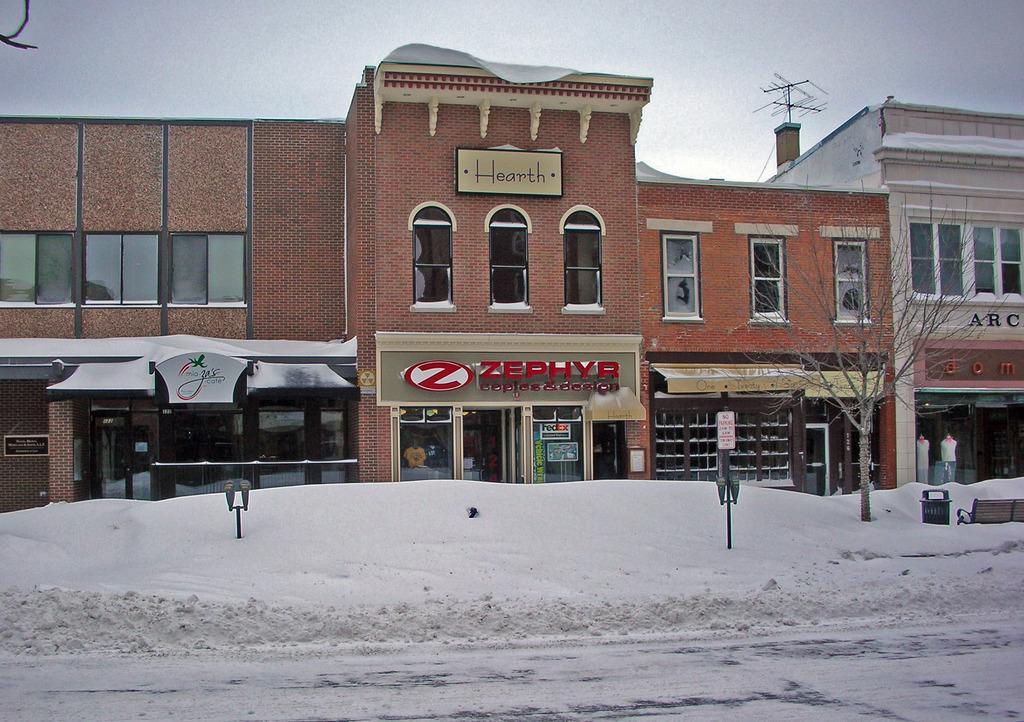Please provide a concise description of this image. In this image we can see the buildings. We can also see the tree and also snow and poles and trash bin and also the bench. At the top there is sky and at the bottom we can see the road which is covered with the snow. 